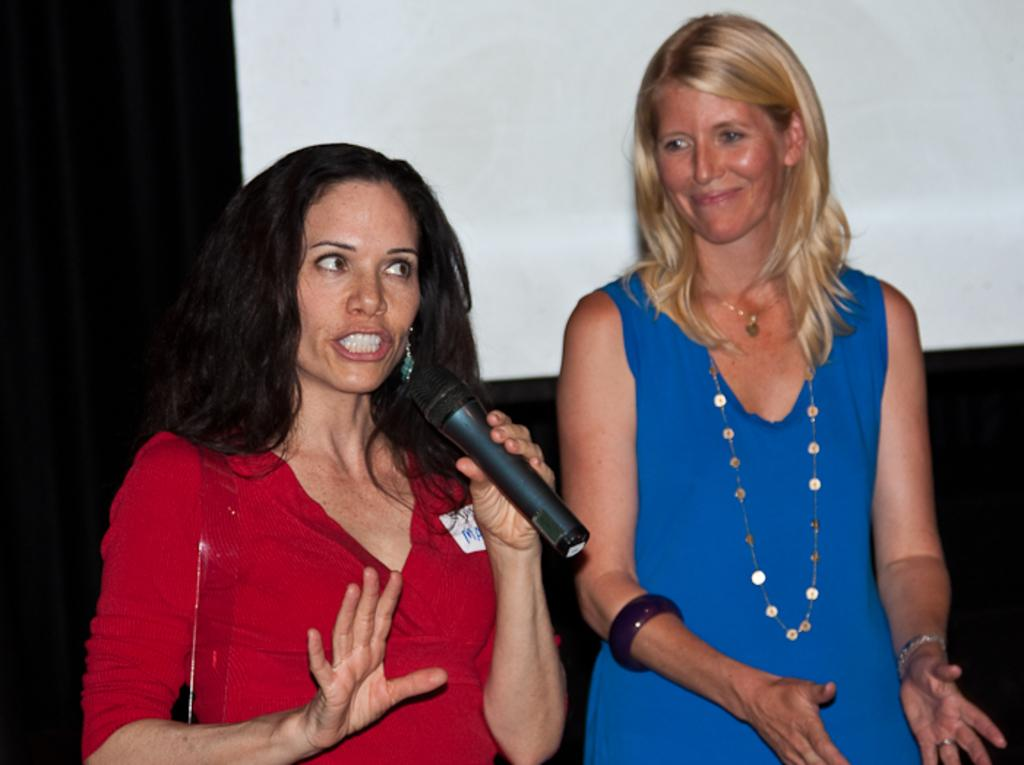What is the woman in the red dress doing in the image? The woman in the red dress is speaking in front of a microphone. Can you describe the other woman in the image? The other woman is wearing a blue dress and smiling. What is the purpose of the microphone in the image? The microphone is likely being used by the woman in the red dress to amplify her voice during her speech. What is the screen on a curtain in the image used for? The screen on a curtain in the image might be used for displaying visual aids or presentations during the speech. How many cats can be seen in the image? There are no cats present in the image. Is there a wound visible on the woman in the blue dress? There is no mention of a wound or any injury in the image. 